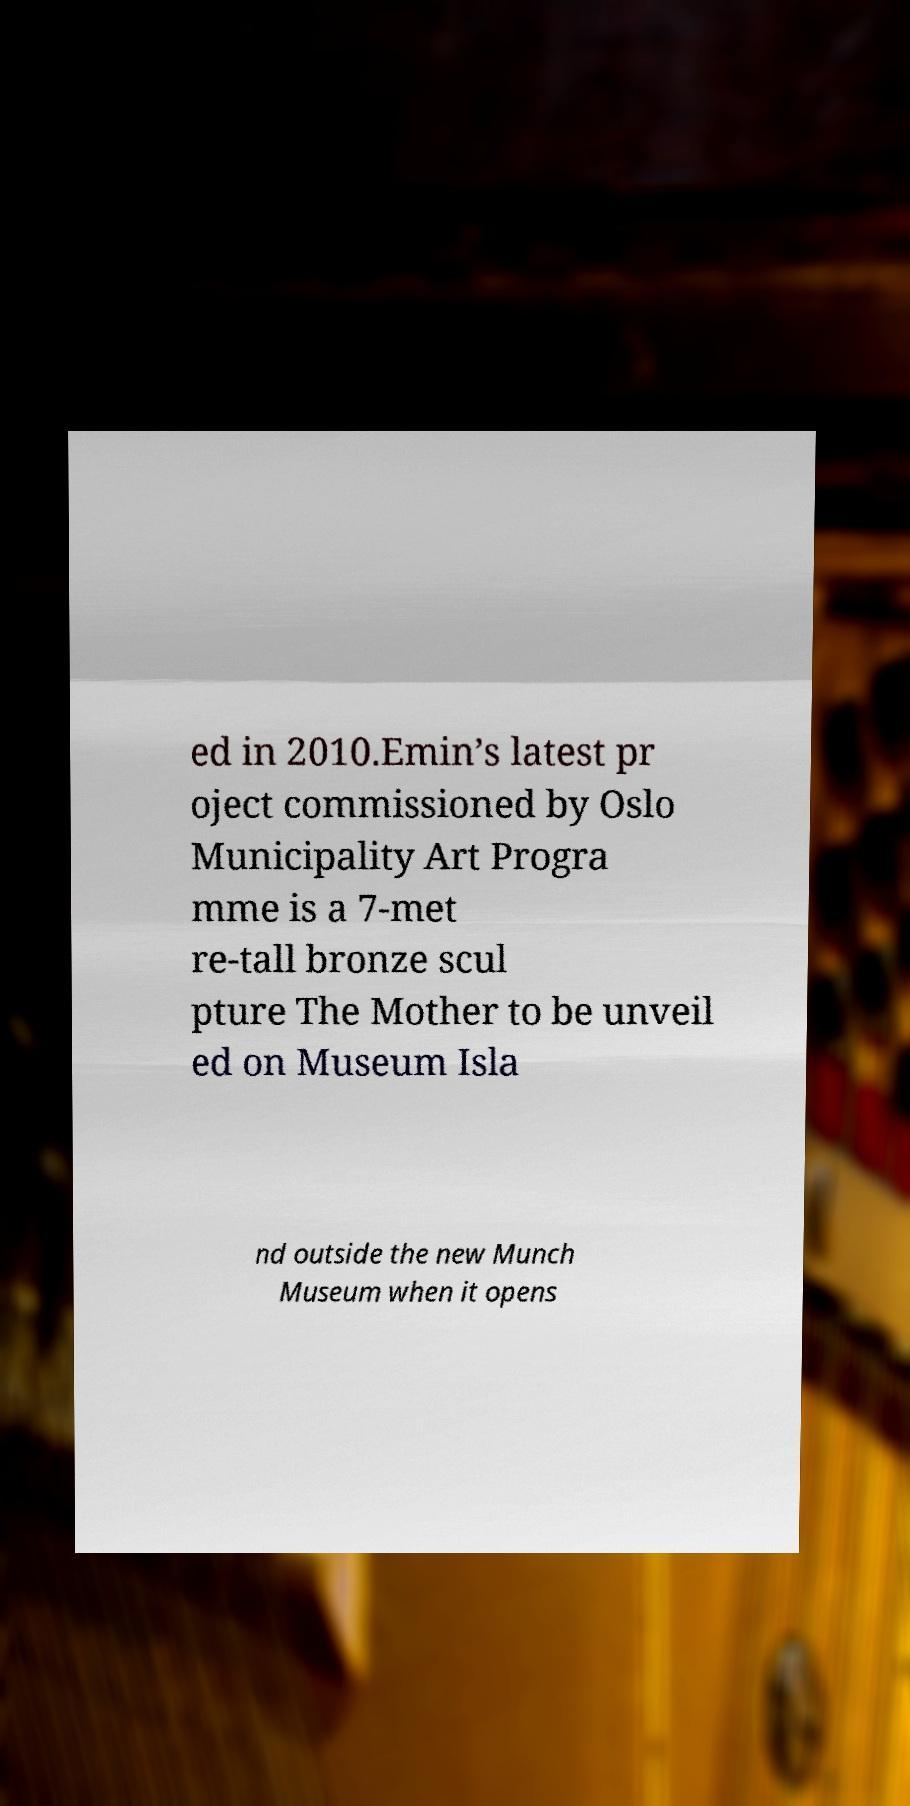Please identify and transcribe the text found in this image. ed in 2010.Emin’s latest pr oject commissioned by Oslo Municipality Art Progra mme is a 7-met re-tall bronze scul pture The Mother to be unveil ed on Museum Isla nd outside the new Munch Museum when it opens 